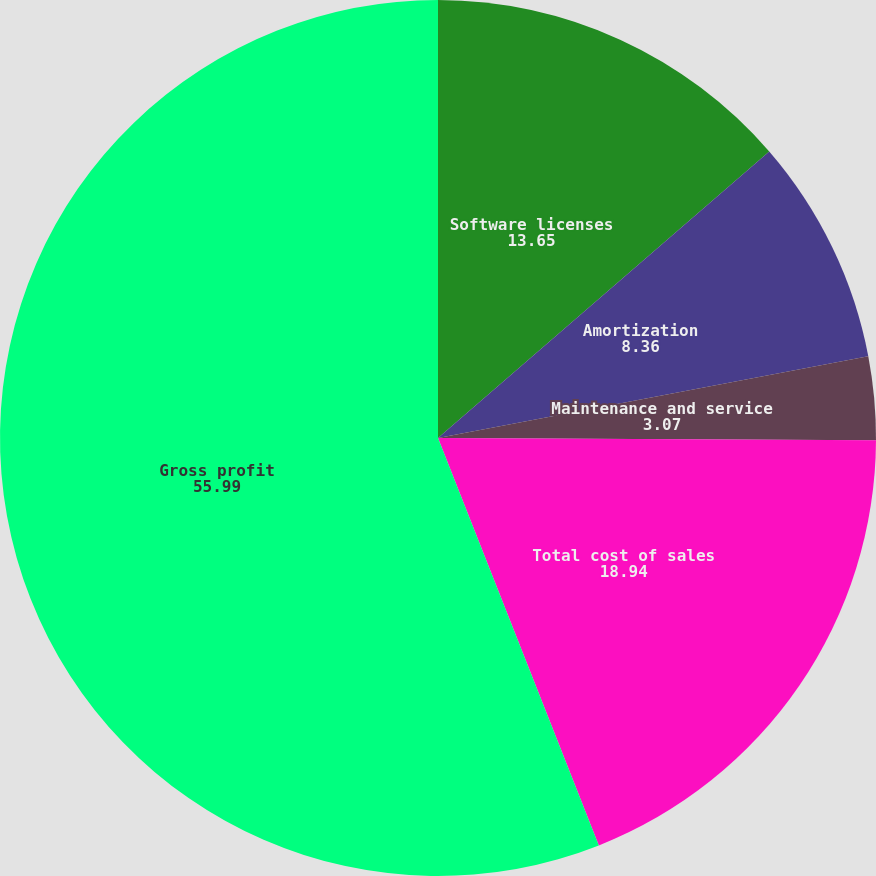Convert chart to OTSL. <chart><loc_0><loc_0><loc_500><loc_500><pie_chart><fcel>Software licenses<fcel>Amortization<fcel>Maintenance and service<fcel>Total cost of sales<fcel>Gross profit<nl><fcel>13.65%<fcel>8.36%<fcel>3.07%<fcel>18.94%<fcel>55.99%<nl></chart> 